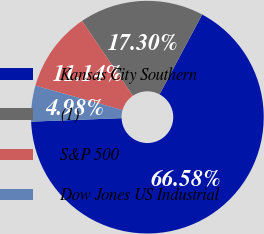Convert chart to OTSL. <chart><loc_0><loc_0><loc_500><loc_500><pie_chart><fcel>Kansas City Southern<fcel>(1)<fcel>S&P 500<fcel>Dow Jones US Industrial<nl><fcel>66.58%<fcel>17.3%<fcel>11.14%<fcel>4.98%<nl></chart> 